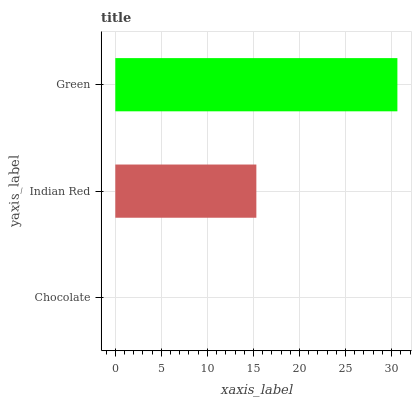Is Chocolate the minimum?
Answer yes or no. Yes. Is Green the maximum?
Answer yes or no. Yes. Is Indian Red the minimum?
Answer yes or no. No. Is Indian Red the maximum?
Answer yes or no. No. Is Indian Red greater than Chocolate?
Answer yes or no. Yes. Is Chocolate less than Indian Red?
Answer yes or no. Yes. Is Chocolate greater than Indian Red?
Answer yes or no. No. Is Indian Red less than Chocolate?
Answer yes or no. No. Is Indian Red the high median?
Answer yes or no. Yes. Is Indian Red the low median?
Answer yes or no. Yes. Is Green the high median?
Answer yes or no. No. Is Green the low median?
Answer yes or no. No. 